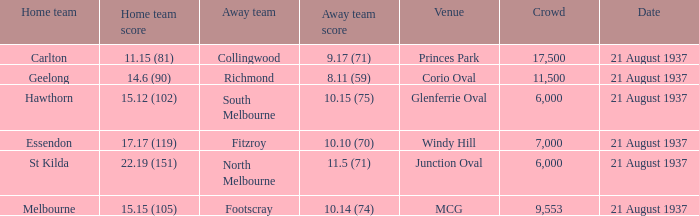Where did richmond compete? Corio Oval. 